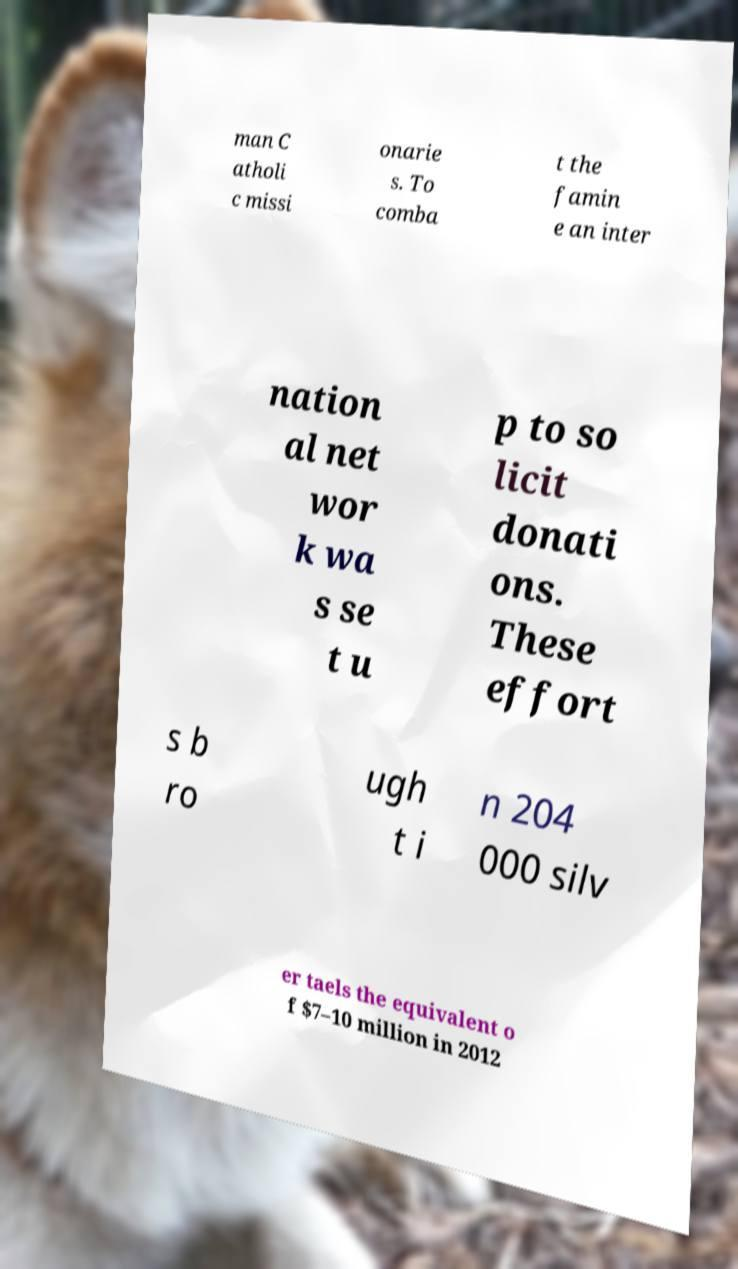Please identify and transcribe the text found in this image. man C atholi c missi onarie s. To comba t the famin e an inter nation al net wor k wa s se t u p to so licit donati ons. These effort s b ro ugh t i n 204 000 silv er taels the equivalent o f $7–10 million in 2012 